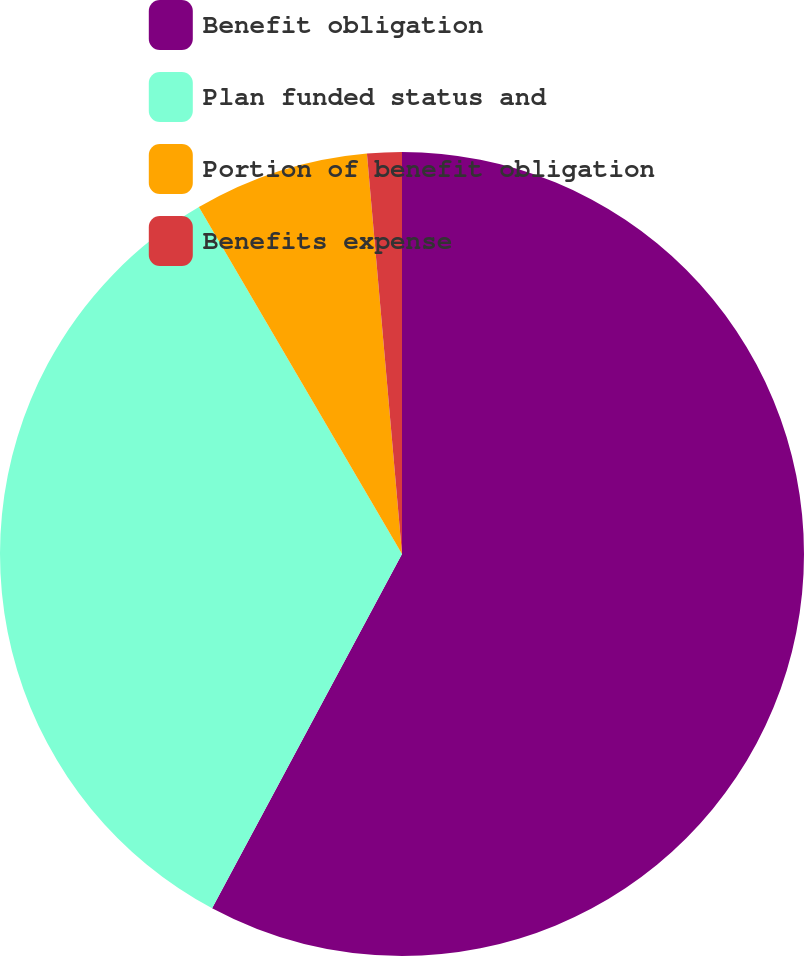Convert chart to OTSL. <chart><loc_0><loc_0><loc_500><loc_500><pie_chart><fcel>Benefit obligation<fcel>Plan funded status and<fcel>Portion of benefit obligation<fcel>Benefits expense<nl><fcel>57.83%<fcel>33.74%<fcel>7.04%<fcel>1.39%<nl></chart> 